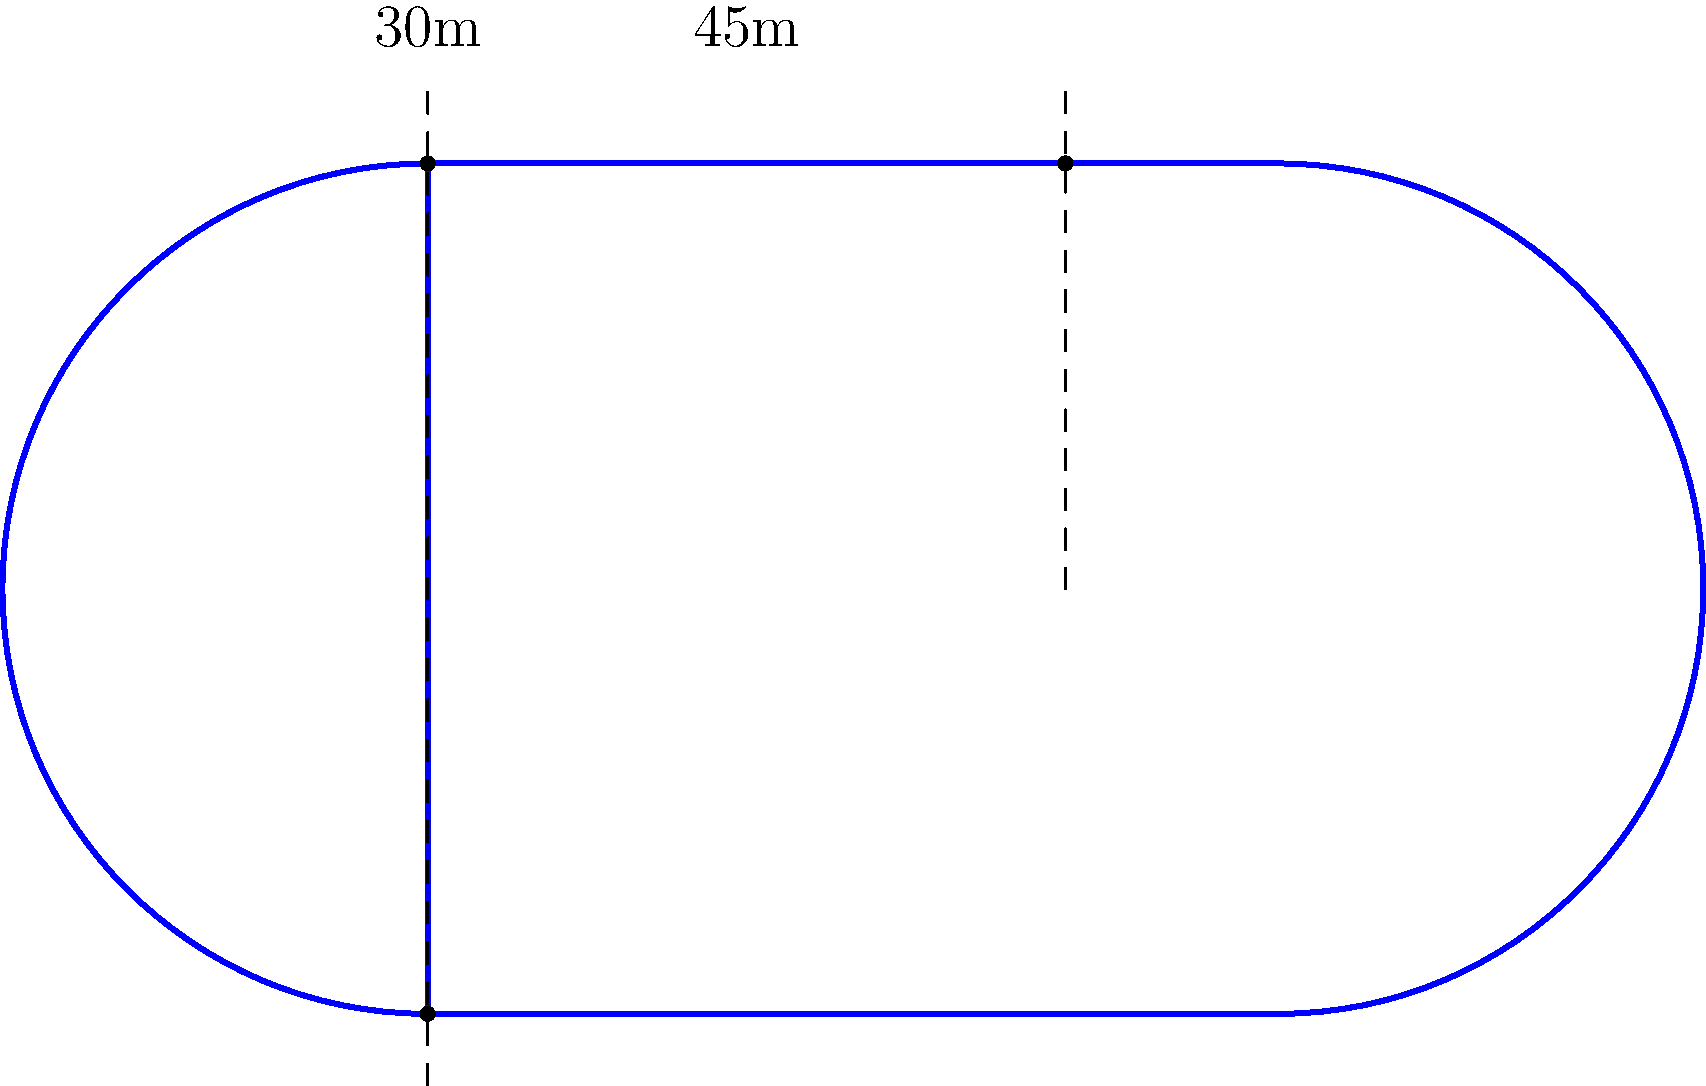A figure-eight-shaped speed skating track consists of two circular loops connected at the center. The straight line distance between the two furthest points of the track is 90m, and the width of each loop is 30m. Calculate the perimeter of the entire track. Let's approach this step-by-step:

1) First, we need to identify the components of the track:
   - Two semicircles (one for each loop)
   - Two straight segments connecting the semicircles

2) Let's calculate the radius of each semicircle:
   - The width of each loop is 30m, which is the diameter of the semicircle
   - So, the radius (r) = 30m / 2 = 15m

3) Calculate the length of one semicircle:
   - Circumference of a full circle = 2πr
   - Length of semicircle = πr = π * 15m = 15πm

4) Now, let's find the length of the straight segments:
   - Total length of the track = 90m
   - Width of two loops = 2 * 30m = 60m
   - Length of straight segments = 90m - 60m = 30m

5) Calculate the total perimeter:
   - Perimeter = (Length of two semicircles) + (Length of two straight segments)
   - Perimeter = (2 * 15πm) + (2 * 30m)
   - Perimeter = 30πm + 60m

6) Simplify:
   Perimeter = 30πm + 60m ≈ 154.25m
Answer: $30\pi + 60$ meters or approximately 154.25 meters 